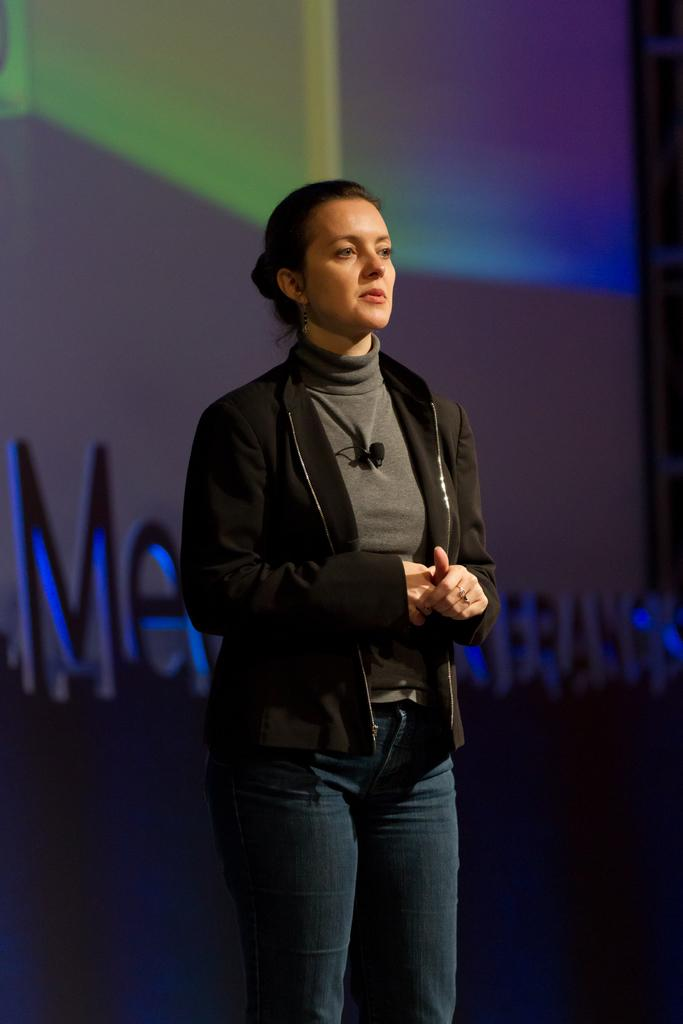Who is present in the image? There is a woman in the image. What is the woman wearing? The woman is wearing a black jacket. Can you describe any accessories or items on the woman's clothing? There is a mic on her shirt. What can be seen in the background of the image? There is a wall in the background of the image. What type of laborer is depicted in the image? There is no laborer depicted in the image; it features a woman with a mic on her shirt. Can you hear the sound of thunder in the image? There is no sound or audio in the image, so it is not possible to hear thunder. 